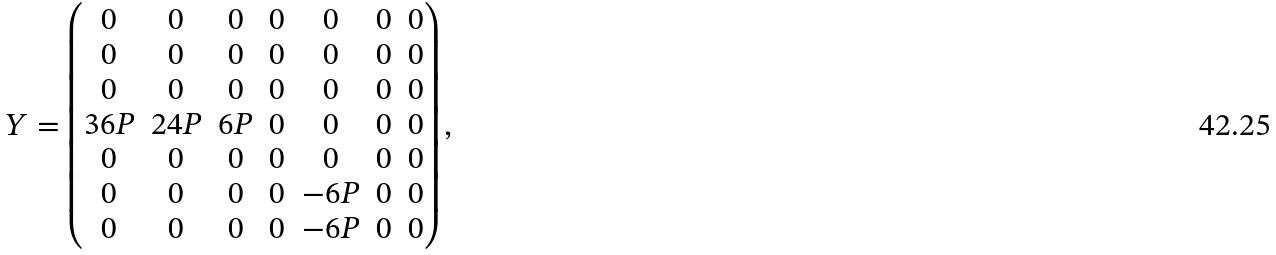Convert formula to latex. <formula><loc_0><loc_0><loc_500><loc_500>Y = \begin{pmatrix} 0 & 0 & 0 & 0 & 0 & 0 & 0 \\ 0 & 0 & 0 & 0 & 0 & 0 & 0 \\ 0 & 0 & 0 & 0 & 0 & 0 & 0 \\ 3 6 P & 2 4 P & 6 P & 0 & 0 & 0 & 0 \\ 0 & 0 & 0 & 0 & 0 & 0 & 0 \\ 0 & 0 & 0 & 0 & - 6 P & 0 & 0 \\ 0 & 0 & 0 & 0 & - 6 P & 0 & 0 \end{pmatrix} ,</formula> 